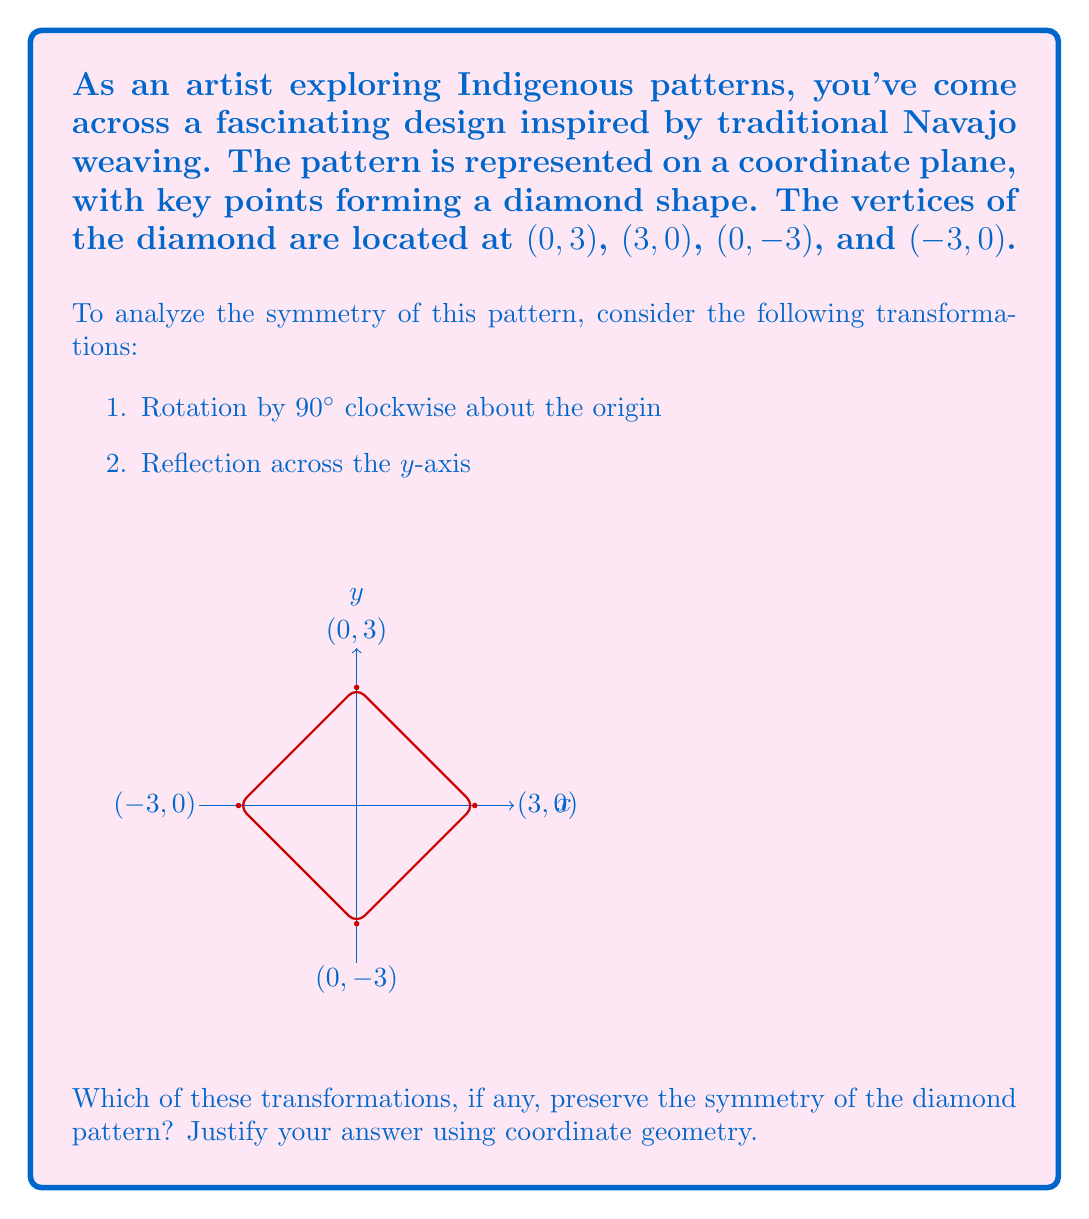Could you help me with this problem? Let's analyze each transformation step-by-step:

1. Rotation by 90° clockwise about the origin:
   The rotation matrix for a 90° clockwise rotation is:
   $$R = \begin{pmatrix} 0 & 1 \\ -1 & 0 \end{pmatrix}$$

   Applying this to each vertex:
   $$(0,3) \rightarrow (3,0)$$
   $$(3,0) \rightarrow (0,-3)$$
   $$(0,-3) \rightarrow (-3,0)$$
   $$(-3,0) \rightarrow (0,3)$$

   We can see that this rotation maps each vertex to another vertex of the diamond, preserving the shape and symmetry.

2. Reflection across the y-axis:
   The transformation matrix for reflection across the y-axis is:
   $$R_y = \begin{pmatrix} -1 & 0 \\ 0 & 1 \end{pmatrix}$$

   Applying this to each vertex:
   $$(0,3) \rightarrow (0,3)$$
   $$(3,0) \rightarrow (-3,0)$$
   $$(0,-3) \rightarrow (0,-3)$$
   $$(-3,0) \rightarrow (3,0)$$

   This reflection also maps each vertex to either itself or another vertex of the diamond, preserving the shape and symmetry.

Both transformations preserve the symmetry of the diamond pattern. This is because:

1. The diamond has rotational symmetry of order 4 (90°, 180°, 270°, 360°) about the origin.
2. The diamond has reflection symmetry across both the x-axis and y-axis.

These properties are consistent with many Indigenous patterns, which often feature high degrees of symmetry and geometric balance.
Answer: Both transformations preserve the symmetry. 